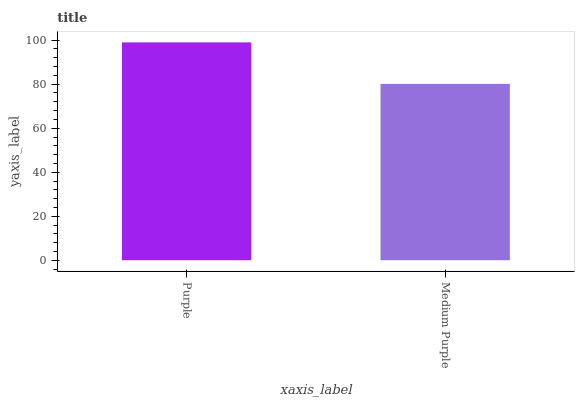Is Medium Purple the minimum?
Answer yes or no. Yes. Is Purple the maximum?
Answer yes or no. Yes. Is Medium Purple the maximum?
Answer yes or no. No. Is Purple greater than Medium Purple?
Answer yes or no. Yes. Is Medium Purple less than Purple?
Answer yes or no. Yes. Is Medium Purple greater than Purple?
Answer yes or no. No. Is Purple less than Medium Purple?
Answer yes or no. No. Is Purple the high median?
Answer yes or no. Yes. Is Medium Purple the low median?
Answer yes or no. Yes. Is Medium Purple the high median?
Answer yes or no. No. Is Purple the low median?
Answer yes or no. No. 